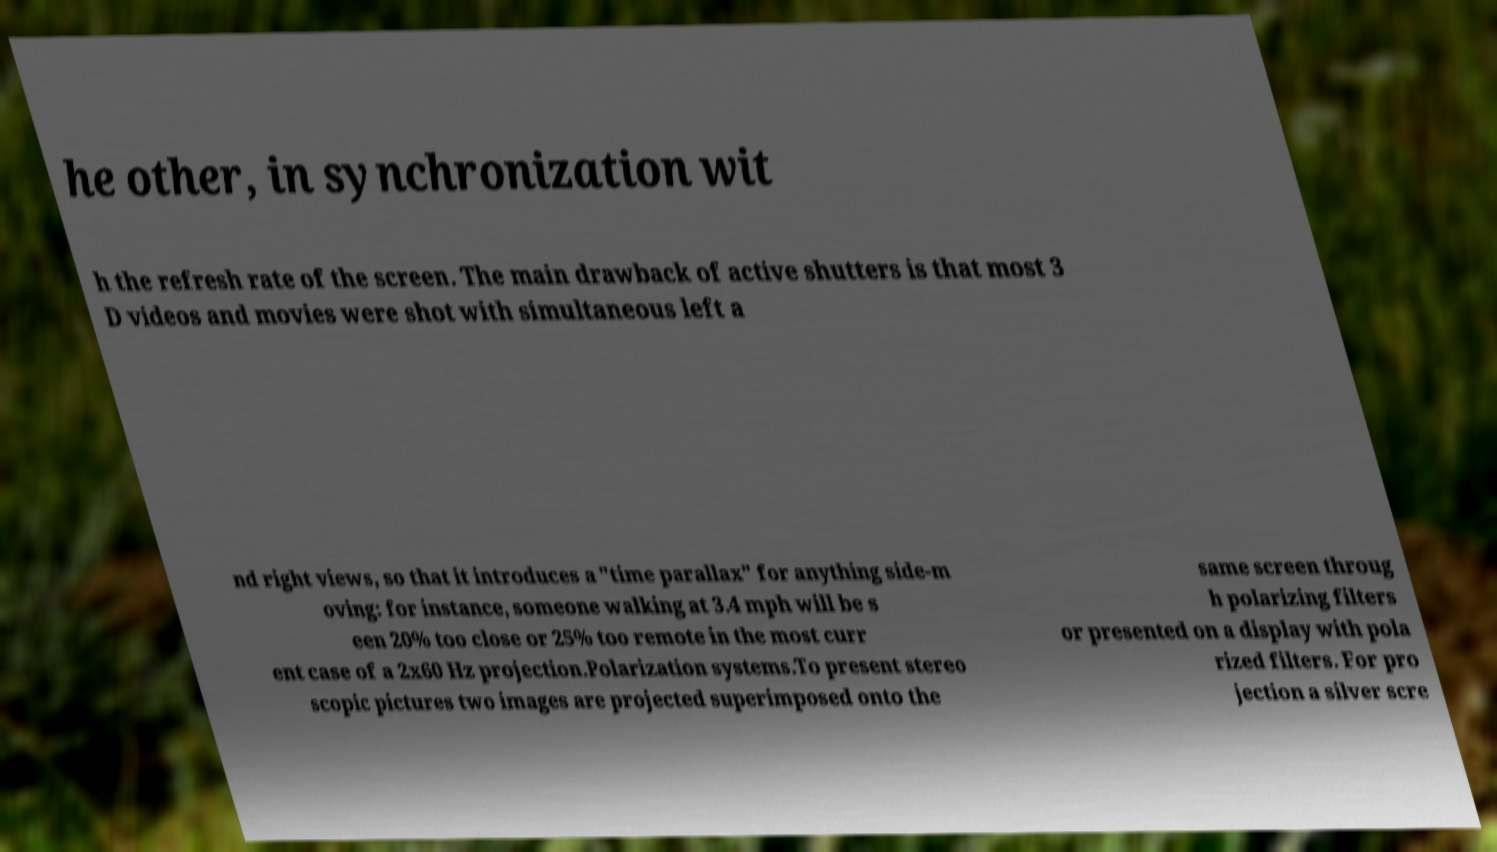Could you assist in decoding the text presented in this image and type it out clearly? he other, in synchronization wit h the refresh rate of the screen. The main drawback of active shutters is that most 3 D videos and movies were shot with simultaneous left a nd right views, so that it introduces a "time parallax" for anything side-m oving: for instance, someone walking at 3.4 mph will be s een 20% too close or 25% too remote in the most curr ent case of a 2x60 Hz projection.Polarization systems.To present stereo scopic pictures two images are projected superimposed onto the same screen throug h polarizing filters or presented on a display with pola rized filters. For pro jection a silver scre 